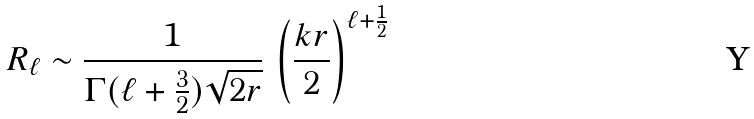<formula> <loc_0><loc_0><loc_500><loc_500>R _ { \ell } \sim { \frac { 1 } { \Gamma ( \ell + { \frac { 3 } { 2 } } ) \sqrt { 2 r } } } \, \left ( { \frac { k r } { 2 } } \right ) ^ { \ell + { \frac { 1 } { 2 } } }</formula> 